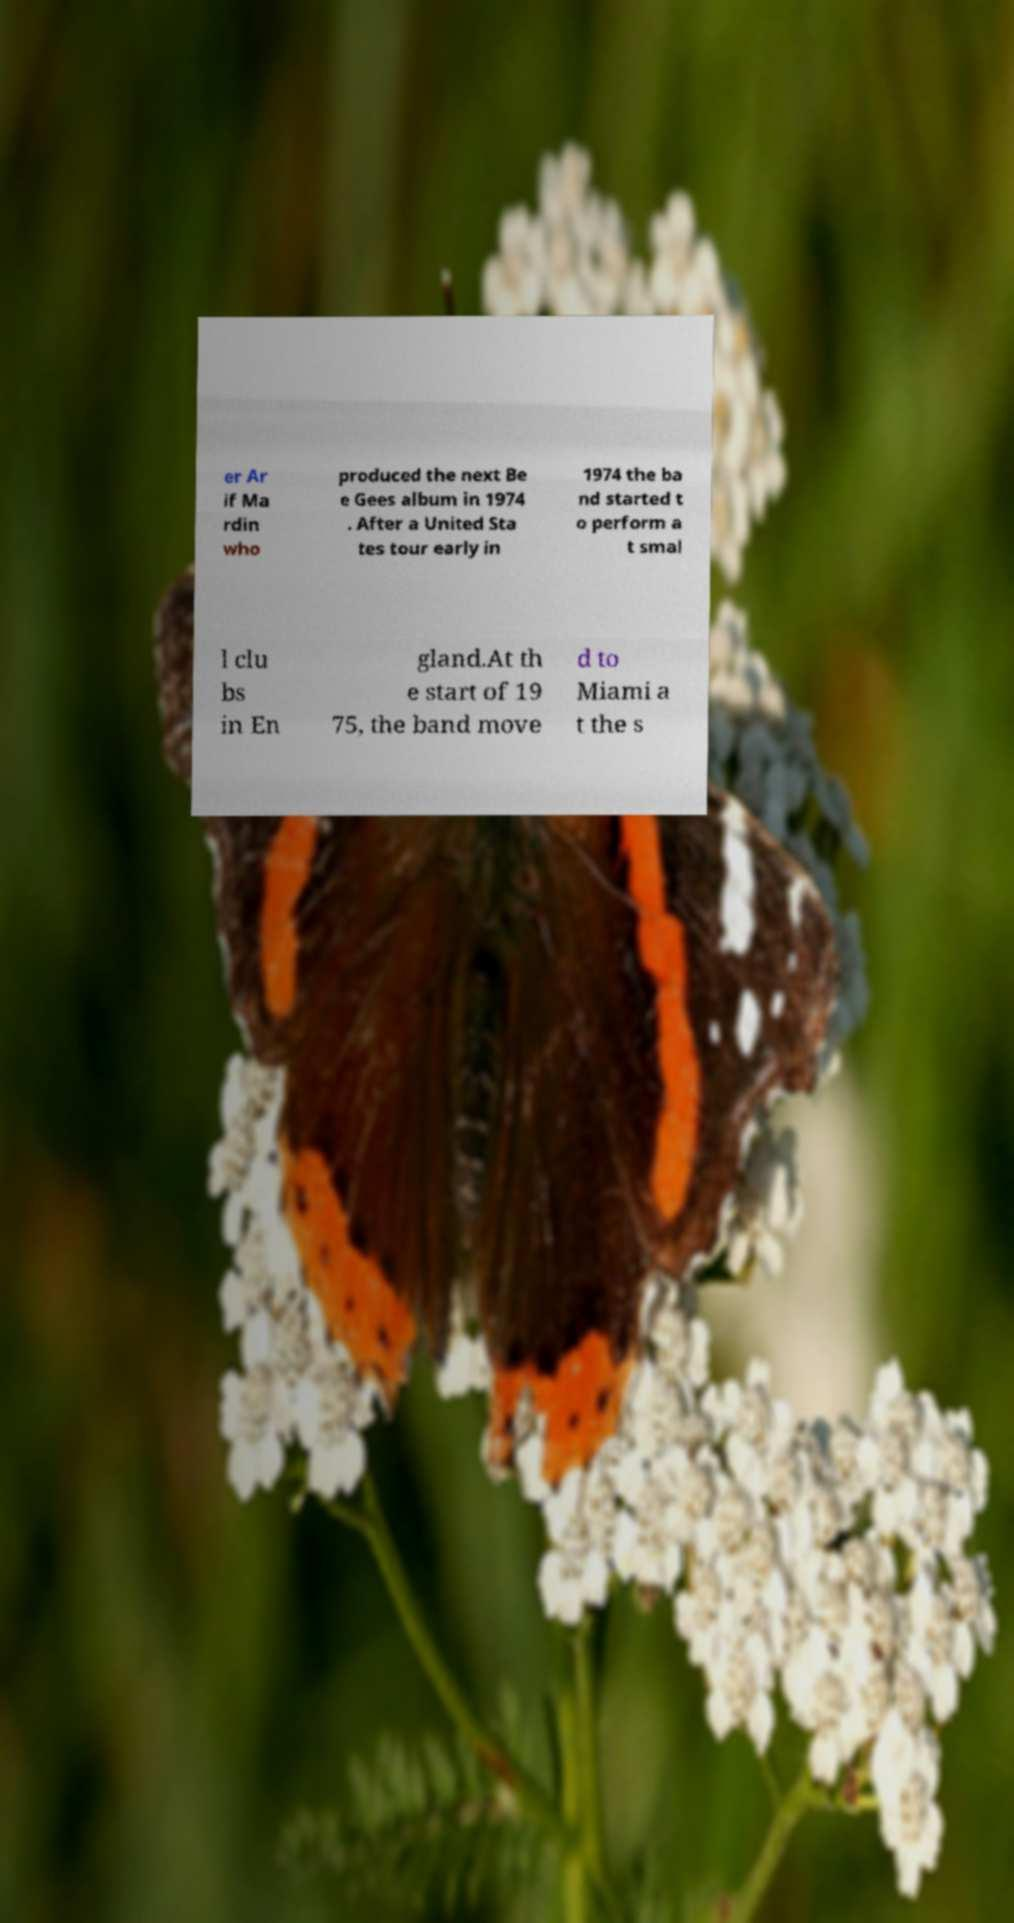For documentation purposes, I need the text within this image transcribed. Could you provide that? er Ar if Ma rdin who produced the next Be e Gees album in 1974 . After a United Sta tes tour early in 1974 the ba nd started t o perform a t smal l clu bs in En gland.At th e start of 19 75, the band move d to Miami a t the s 